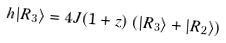<formula> <loc_0><loc_0><loc_500><loc_500>h | R _ { 3 } \rangle = 4 J ( 1 + z ) \left ( | R _ { 3 } \rangle + | R _ { 2 } \rangle \right )</formula> 